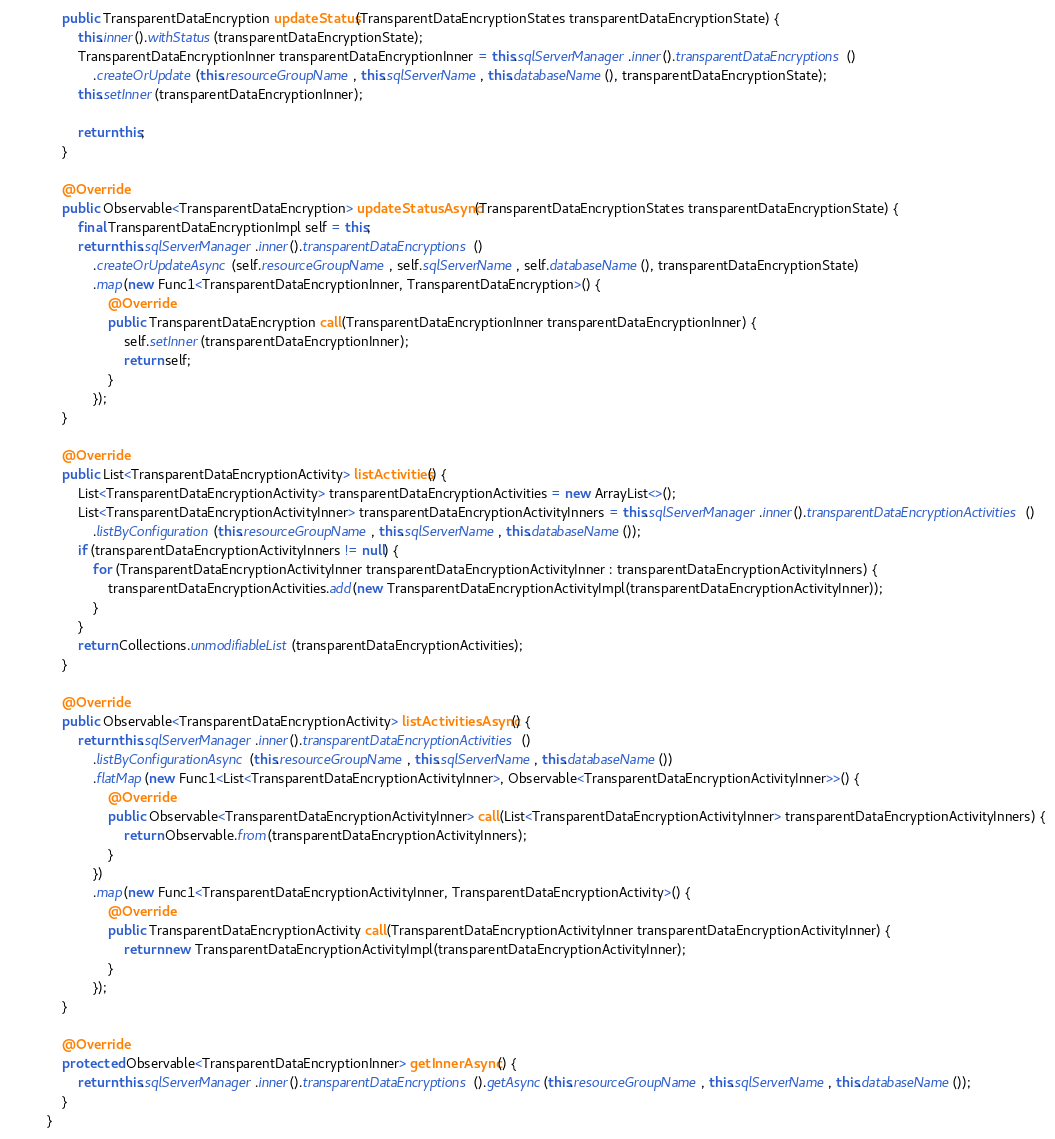<code> <loc_0><loc_0><loc_500><loc_500><_Java_>    public TransparentDataEncryption updateStatus(TransparentDataEncryptionStates transparentDataEncryptionState) {
        this.inner().withStatus(transparentDataEncryptionState);
        TransparentDataEncryptionInner transparentDataEncryptionInner = this.sqlServerManager.inner().transparentDataEncryptions()
            .createOrUpdate(this.resourceGroupName, this.sqlServerName, this.databaseName(), transparentDataEncryptionState);
        this.setInner(transparentDataEncryptionInner);

        return this;
    }

    @Override
    public Observable<TransparentDataEncryption> updateStatusAsync(TransparentDataEncryptionStates transparentDataEncryptionState) {
        final TransparentDataEncryptionImpl self = this;
        return this.sqlServerManager.inner().transparentDataEncryptions()
            .createOrUpdateAsync(self.resourceGroupName, self.sqlServerName, self.databaseName(), transparentDataEncryptionState)
            .map(new Func1<TransparentDataEncryptionInner, TransparentDataEncryption>() {
                @Override
                public TransparentDataEncryption call(TransparentDataEncryptionInner transparentDataEncryptionInner) {
                    self.setInner(transparentDataEncryptionInner);
                    return self;
                }
            });
    }

    @Override
    public List<TransparentDataEncryptionActivity> listActivities() {
        List<TransparentDataEncryptionActivity> transparentDataEncryptionActivities = new ArrayList<>();
        List<TransparentDataEncryptionActivityInner> transparentDataEncryptionActivityInners = this.sqlServerManager.inner().transparentDataEncryptionActivities()
            .listByConfiguration(this.resourceGroupName, this.sqlServerName, this.databaseName());
        if (transparentDataEncryptionActivityInners != null) {
            for (TransparentDataEncryptionActivityInner transparentDataEncryptionActivityInner : transparentDataEncryptionActivityInners) {
                transparentDataEncryptionActivities.add(new TransparentDataEncryptionActivityImpl(transparentDataEncryptionActivityInner));
            }
        }
        return Collections.unmodifiableList(transparentDataEncryptionActivities);
    }

    @Override
    public Observable<TransparentDataEncryptionActivity> listActivitiesAsync() {
        return this.sqlServerManager.inner().transparentDataEncryptionActivities()
            .listByConfigurationAsync(this.resourceGroupName, this.sqlServerName, this.databaseName())
            .flatMap(new Func1<List<TransparentDataEncryptionActivityInner>, Observable<TransparentDataEncryptionActivityInner>>() {
                @Override
                public Observable<TransparentDataEncryptionActivityInner> call(List<TransparentDataEncryptionActivityInner> transparentDataEncryptionActivityInners) {
                    return Observable.from(transparentDataEncryptionActivityInners);
                }
            })
            .map(new Func1<TransparentDataEncryptionActivityInner, TransparentDataEncryptionActivity>() {
                @Override
                public TransparentDataEncryptionActivity call(TransparentDataEncryptionActivityInner transparentDataEncryptionActivityInner) {
                    return new TransparentDataEncryptionActivityImpl(transparentDataEncryptionActivityInner);
                }
            });
    }

    @Override
    protected Observable<TransparentDataEncryptionInner> getInnerAsync() {
        return this.sqlServerManager.inner().transparentDataEncryptions().getAsync(this.resourceGroupName, this.sqlServerName, this.databaseName());
    }
}
</code> 